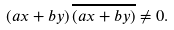<formula> <loc_0><loc_0><loc_500><loc_500>\left ( a x + b y \right ) \overline { \left ( a x + b y \right ) } \neq 0 .</formula> 